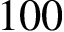Convert formula to latex. <formula><loc_0><loc_0><loc_500><loc_500>1 0 0</formula> 